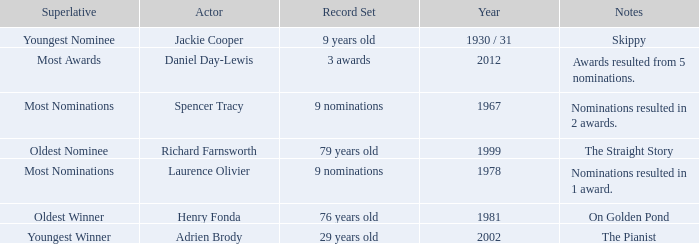What actor won in 1978? Laurence Olivier. 